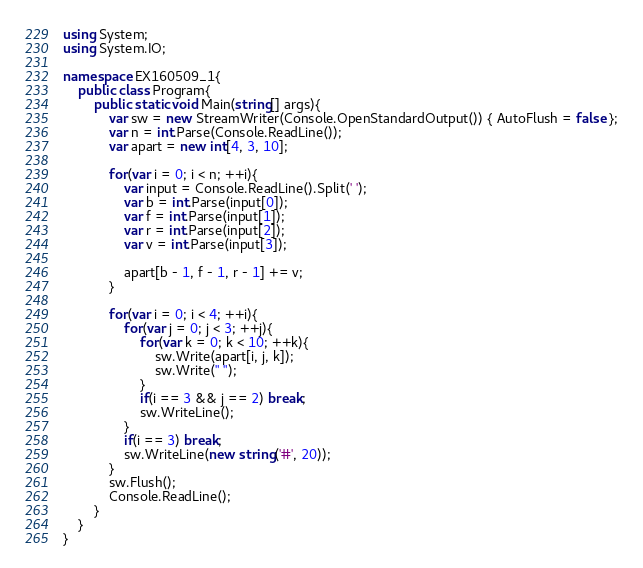<code> <loc_0><loc_0><loc_500><loc_500><_C#_>using System;
using System.IO;

namespace EX160509_1{
    public class Program{
        public static void Main(string[] args){
            var sw = new StreamWriter(Console.OpenStandardOutput()) { AutoFlush = false };
            var n = int.Parse(Console.ReadLine());
            var apart = new int[4, 3, 10];

            for(var i = 0; i < n; ++i){
                var input = Console.ReadLine().Split(' ');
                var b = int.Parse(input[0]);
                var f = int.Parse(input[1]);
                var r = int.Parse(input[2]);
                var v = int.Parse(input[3]);

                apart[b - 1, f - 1, r - 1] += v;
            }

            for(var i = 0; i < 4; ++i){
                for(var j = 0; j < 3; ++j){
                    for(var k = 0; k < 10; ++k){
                        sw.Write(apart[i, j, k]);
                        sw.Write(" ");
                    }
                    if(i == 3 && j == 2) break;
                    sw.WriteLine();
                }
                if(i == 3) break;
                sw.WriteLine(new string('#', 20));
            }
            sw.Flush();
            Console.ReadLine();
        }
    }
}</code> 